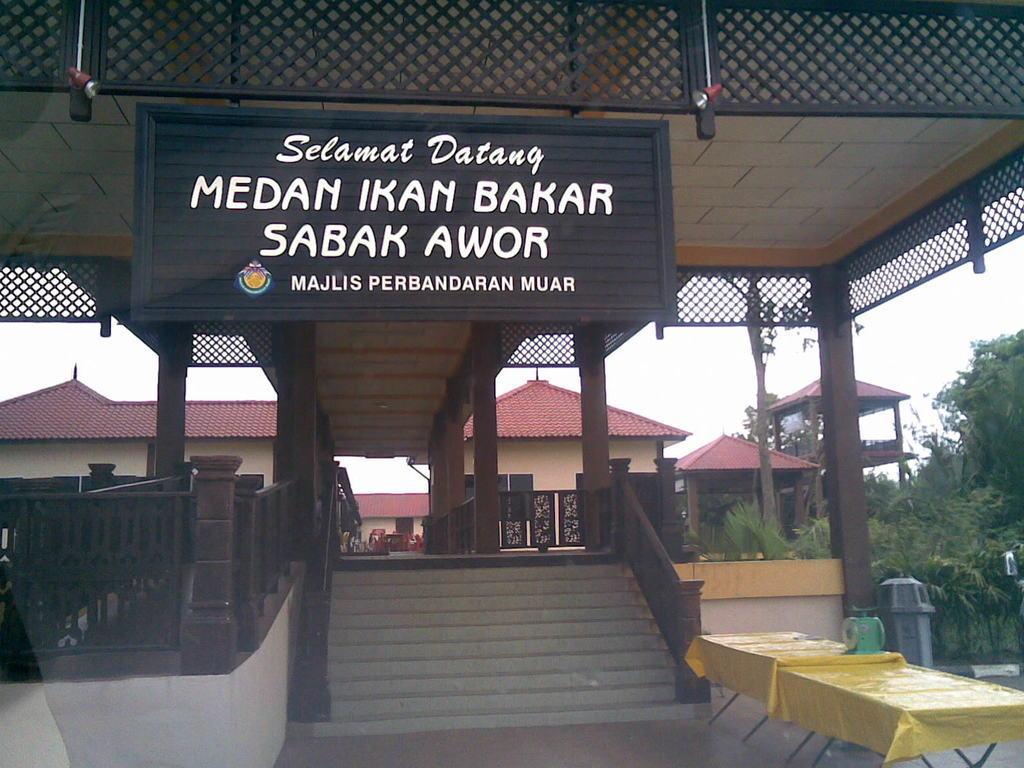Describe this image in one or two sentences. In this image there are stairs at bottom of this image and there are two tables at bottom right corner of there image. there are some trees at right side of this image. there is a building in middle of this image. there is a board written on it at top of the image. and there is a sky as we can see from right side of this image and left side of this image. There is a yellow color cloth kept on this tablet. 